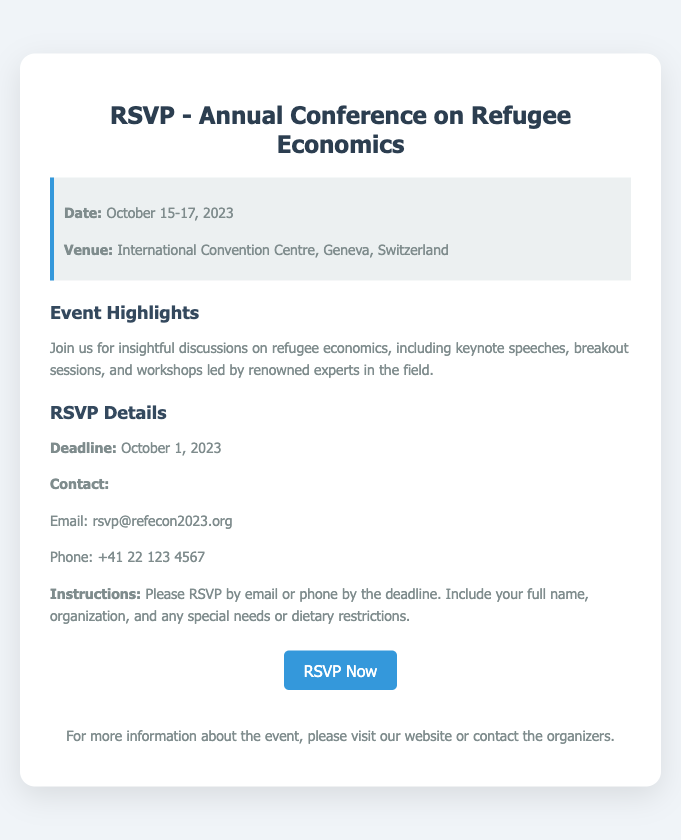what are the dates of the conference? The dates of the conference are mentioned clearly in the document.
Answer: October 15-17, 2023 where is the conference venue located? The venue location is provided at the beginning of the document under venue information.
Answer: International Convention Centre, Geneva, Switzerland what is the RSVP deadline? The RSVP deadline is stated within the RSVP details section.
Answer: October 1, 2023 what should be included when RSVP-ing? The document specifies what details to include in the RSVP instructions.
Answer: Full name, organization, and any special needs or dietary restrictions how can one RSVP for the conference? The RSVP method is explained in the RSVP details section of the document.
Answer: By email or phone who can be contacted for more information? Contact information is provided for the RSVP process in the document.
Answer: rsvp@refecon2023.org what will the conference discuss? A brief overview of the conference topics is provided in the event highlights section.
Answer: Refugee economics how many days will the conference last? The total duration of the conference can be inferred from the provided dates.
Answer: Three days 